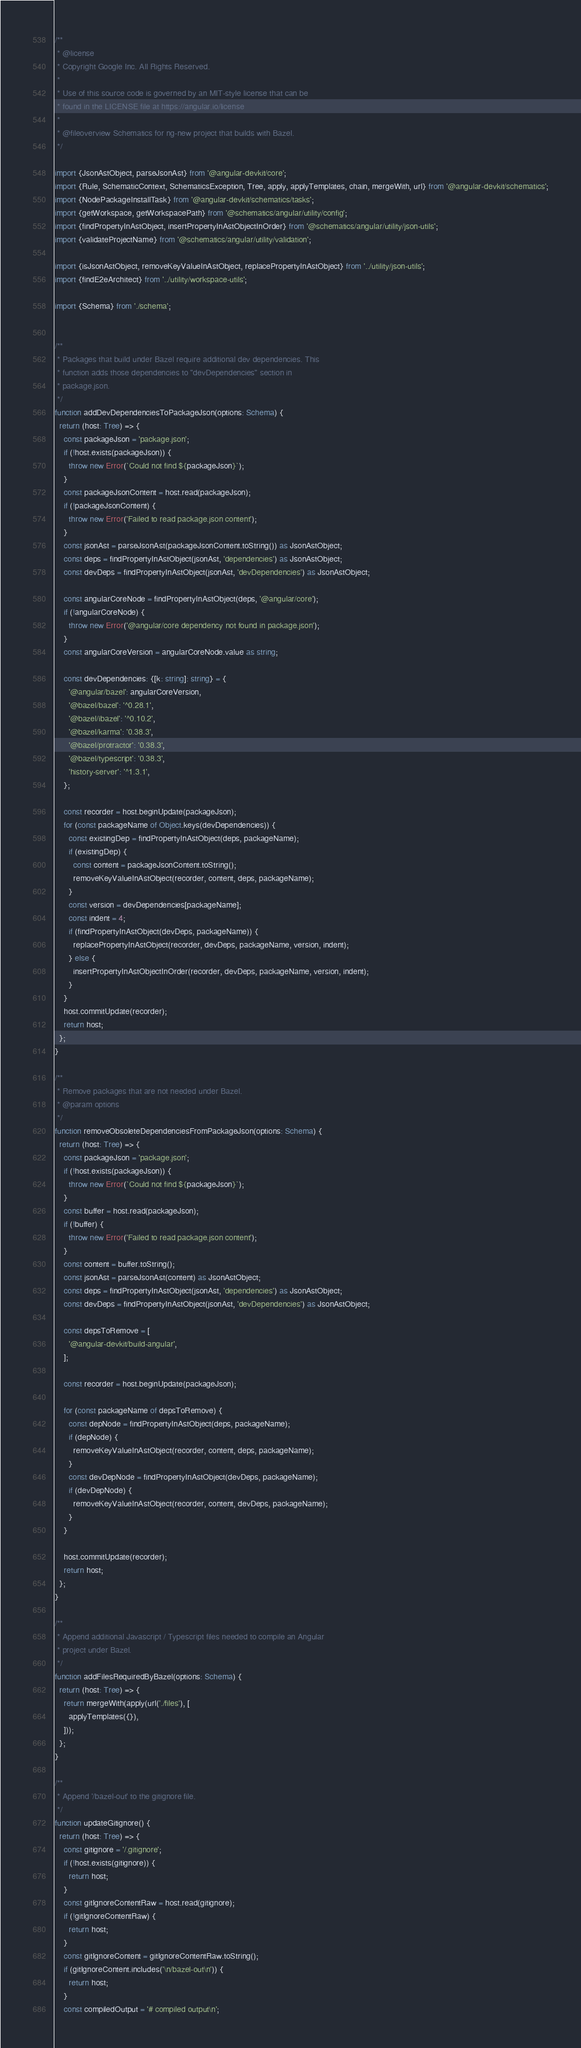<code> <loc_0><loc_0><loc_500><loc_500><_TypeScript_>/**
 * @license
 * Copyright Google Inc. All Rights Reserved.
 *
 * Use of this source code is governed by an MIT-style license that can be
 * found in the LICENSE file at https://angular.io/license
 *
 * @fileoverview Schematics for ng-new project that builds with Bazel.
 */

import {JsonAstObject, parseJsonAst} from '@angular-devkit/core';
import {Rule, SchematicContext, SchematicsException, Tree, apply, applyTemplates, chain, mergeWith, url} from '@angular-devkit/schematics';
import {NodePackageInstallTask} from '@angular-devkit/schematics/tasks';
import {getWorkspace, getWorkspacePath} from '@schematics/angular/utility/config';
import {findPropertyInAstObject, insertPropertyInAstObjectInOrder} from '@schematics/angular/utility/json-utils';
import {validateProjectName} from '@schematics/angular/utility/validation';

import {isJsonAstObject, removeKeyValueInAstObject, replacePropertyInAstObject} from '../utility/json-utils';
import {findE2eArchitect} from '../utility/workspace-utils';

import {Schema} from './schema';


/**
 * Packages that build under Bazel require additional dev dependencies. This
 * function adds those dependencies to "devDependencies" section in
 * package.json.
 */
function addDevDependenciesToPackageJson(options: Schema) {
  return (host: Tree) => {
    const packageJson = 'package.json';
    if (!host.exists(packageJson)) {
      throw new Error(`Could not find ${packageJson}`);
    }
    const packageJsonContent = host.read(packageJson);
    if (!packageJsonContent) {
      throw new Error('Failed to read package.json content');
    }
    const jsonAst = parseJsonAst(packageJsonContent.toString()) as JsonAstObject;
    const deps = findPropertyInAstObject(jsonAst, 'dependencies') as JsonAstObject;
    const devDeps = findPropertyInAstObject(jsonAst, 'devDependencies') as JsonAstObject;

    const angularCoreNode = findPropertyInAstObject(deps, '@angular/core');
    if (!angularCoreNode) {
      throw new Error('@angular/core dependency not found in package.json');
    }
    const angularCoreVersion = angularCoreNode.value as string;

    const devDependencies: {[k: string]: string} = {
      '@angular/bazel': angularCoreVersion,
      '@bazel/bazel': '^0.28.1',
      '@bazel/ibazel': '^0.10.2',
      '@bazel/karma': '0.38.3',
      '@bazel/protractor': '0.38.3',
      '@bazel/typescript': '0.38.3',
      'history-server': '^1.3.1',
    };

    const recorder = host.beginUpdate(packageJson);
    for (const packageName of Object.keys(devDependencies)) {
      const existingDep = findPropertyInAstObject(deps, packageName);
      if (existingDep) {
        const content = packageJsonContent.toString();
        removeKeyValueInAstObject(recorder, content, deps, packageName);
      }
      const version = devDependencies[packageName];
      const indent = 4;
      if (findPropertyInAstObject(devDeps, packageName)) {
        replacePropertyInAstObject(recorder, devDeps, packageName, version, indent);
      } else {
        insertPropertyInAstObjectInOrder(recorder, devDeps, packageName, version, indent);
      }
    }
    host.commitUpdate(recorder);
    return host;
  };
}

/**
 * Remove packages that are not needed under Bazel.
 * @param options
 */
function removeObsoleteDependenciesFromPackageJson(options: Schema) {
  return (host: Tree) => {
    const packageJson = 'package.json';
    if (!host.exists(packageJson)) {
      throw new Error(`Could not find ${packageJson}`);
    }
    const buffer = host.read(packageJson);
    if (!buffer) {
      throw new Error('Failed to read package.json content');
    }
    const content = buffer.toString();
    const jsonAst = parseJsonAst(content) as JsonAstObject;
    const deps = findPropertyInAstObject(jsonAst, 'dependencies') as JsonAstObject;
    const devDeps = findPropertyInAstObject(jsonAst, 'devDependencies') as JsonAstObject;

    const depsToRemove = [
      '@angular-devkit/build-angular',
    ];

    const recorder = host.beginUpdate(packageJson);

    for (const packageName of depsToRemove) {
      const depNode = findPropertyInAstObject(deps, packageName);
      if (depNode) {
        removeKeyValueInAstObject(recorder, content, deps, packageName);
      }
      const devDepNode = findPropertyInAstObject(devDeps, packageName);
      if (devDepNode) {
        removeKeyValueInAstObject(recorder, content, devDeps, packageName);
      }
    }

    host.commitUpdate(recorder);
    return host;
  };
}

/**
 * Append additional Javascript / Typescript files needed to compile an Angular
 * project under Bazel.
 */
function addFilesRequiredByBazel(options: Schema) {
  return (host: Tree) => {
    return mergeWith(apply(url('./files'), [
      applyTemplates({}),
    ]));
  };
}

/**
 * Append '/bazel-out' to the gitignore file.
 */
function updateGitignore() {
  return (host: Tree) => {
    const gitignore = '/.gitignore';
    if (!host.exists(gitignore)) {
      return host;
    }
    const gitIgnoreContentRaw = host.read(gitignore);
    if (!gitIgnoreContentRaw) {
      return host;
    }
    const gitIgnoreContent = gitIgnoreContentRaw.toString();
    if (gitIgnoreContent.includes('\n/bazel-out\n')) {
      return host;
    }
    const compiledOutput = '# compiled output\n';</code> 